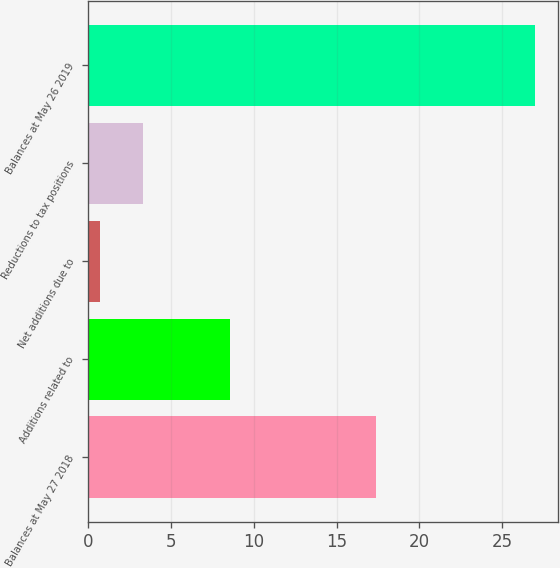Convert chart to OTSL. <chart><loc_0><loc_0><loc_500><loc_500><bar_chart><fcel>Balances at May 27 2018<fcel>Additions related to<fcel>Net additions due to<fcel>Reductions to tax positions<fcel>Balances at May 26 2019<nl><fcel>17.4<fcel>8.59<fcel>0.7<fcel>3.33<fcel>27<nl></chart> 